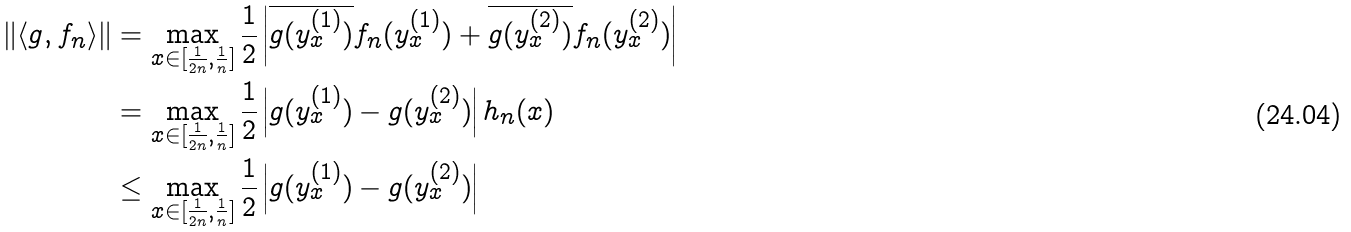Convert formula to latex. <formula><loc_0><loc_0><loc_500><loc_500>\| \langle g , f _ { n } \rangle \| & = \max _ { x \in [ \frac { 1 } { 2 n } , \frac { 1 } { n } ] } \frac { 1 } { 2 } \left | \overline { g ( y _ { x } ^ { ( 1 ) } ) } f _ { n } ( y _ { x } ^ { ( 1 ) } ) + \overline { g ( y _ { x } ^ { ( 2 ) } ) } f _ { n } ( y _ { x } ^ { ( 2 ) } ) \right | \\ & = \max _ { x \in [ \frac { 1 } { 2 n } , \frac { 1 } { n } ] } \frac { 1 } { 2 } \left | { g ( y _ { x } ^ { ( 1 ) } ) } - { g ( y _ { x } ^ { ( 2 ) } ) } \right | h _ { n } ( x ) \\ & \leq \max _ { x \in [ \frac { 1 } { 2 n } , \frac { 1 } { n } ] } \frac { 1 } { 2 } \left | { g ( y _ { x } ^ { ( 1 ) } ) } - { g ( y _ { x } ^ { ( 2 ) } ) } \right |</formula> 